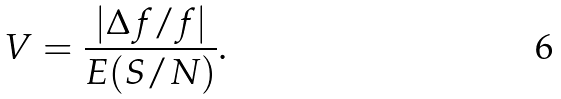<formula> <loc_0><loc_0><loc_500><loc_500>V = \frac { | \Delta { f / f } | } { E ( S / N ) } .</formula> 